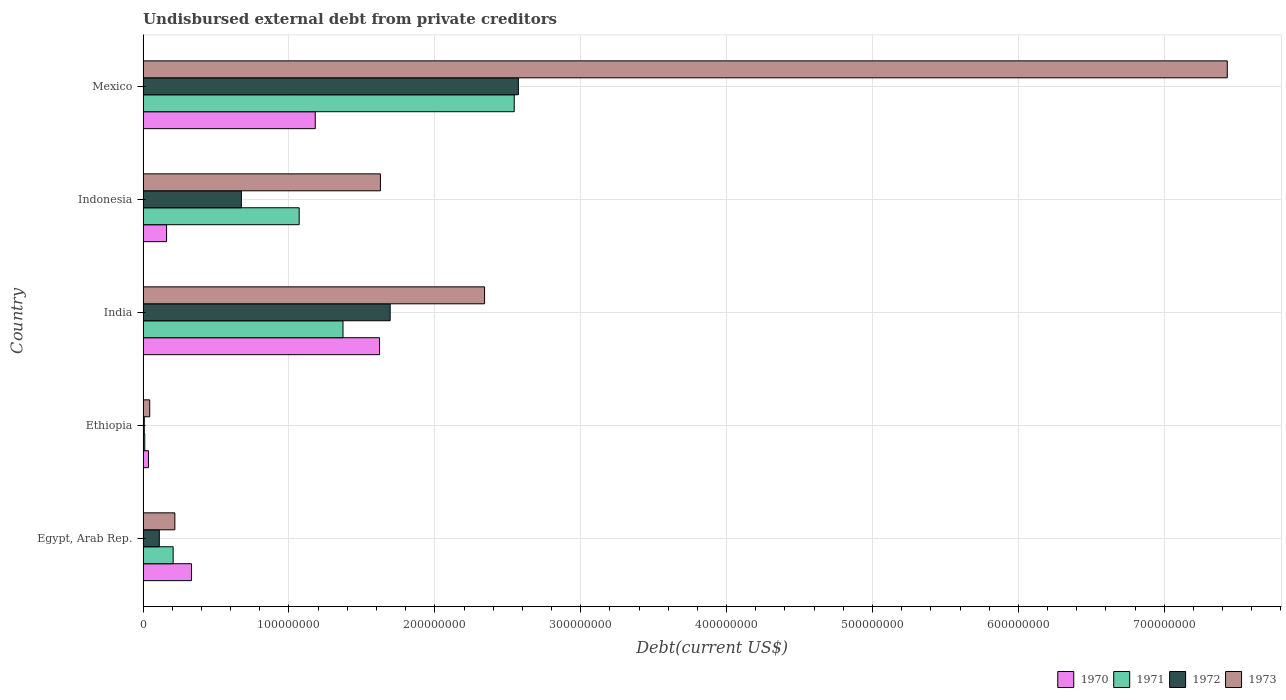Are the number of bars on each tick of the Y-axis equal?
Give a very brief answer. Yes. How many bars are there on the 3rd tick from the top?
Your answer should be very brief. 4. How many bars are there on the 1st tick from the bottom?
Your answer should be compact. 4. What is the label of the 4th group of bars from the top?
Ensure brevity in your answer.  Ethiopia. In how many cases, is the number of bars for a given country not equal to the number of legend labels?
Offer a terse response. 0. What is the total debt in 1970 in Indonesia?
Offer a very short reply. 1.61e+07. Across all countries, what is the maximum total debt in 1972?
Provide a short and direct response. 2.57e+08. Across all countries, what is the minimum total debt in 1970?
Provide a short and direct response. 3.70e+06. In which country was the total debt in 1973 minimum?
Keep it short and to the point. Ethiopia. What is the total total debt in 1973 in the graph?
Provide a short and direct response. 1.17e+09. What is the difference between the total debt in 1972 in Indonesia and that in Mexico?
Your answer should be compact. -1.90e+08. What is the difference between the total debt in 1971 in India and the total debt in 1973 in Indonesia?
Keep it short and to the point. -2.56e+07. What is the average total debt in 1970 per country?
Your answer should be compact. 6.66e+07. What is the difference between the total debt in 1971 and total debt in 1973 in Egypt, Arab Rep.?
Your response must be concise. -1.17e+06. In how many countries, is the total debt in 1973 greater than 460000000 US$?
Offer a terse response. 1. What is the ratio of the total debt in 1972 in Egypt, Arab Rep. to that in India?
Make the answer very short. 0.07. Is the total debt in 1972 in India less than that in Mexico?
Provide a succinct answer. Yes. What is the difference between the highest and the second highest total debt in 1971?
Keep it short and to the point. 1.17e+08. What is the difference between the highest and the lowest total debt in 1973?
Keep it short and to the point. 7.39e+08. In how many countries, is the total debt in 1971 greater than the average total debt in 1971 taken over all countries?
Give a very brief answer. 3. Is the sum of the total debt in 1970 in India and Indonesia greater than the maximum total debt in 1973 across all countries?
Make the answer very short. No. What does the 1st bar from the top in India represents?
Provide a short and direct response. 1973. Are all the bars in the graph horizontal?
Offer a very short reply. Yes. How many countries are there in the graph?
Your response must be concise. 5. What is the difference between two consecutive major ticks on the X-axis?
Offer a terse response. 1.00e+08. Are the values on the major ticks of X-axis written in scientific E-notation?
Ensure brevity in your answer.  No. Does the graph contain any zero values?
Ensure brevity in your answer.  No. Does the graph contain grids?
Your answer should be very brief. Yes. Where does the legend appear in the graph?
Ensure brevity in your answer.  Bottom right. How are the legend labels stacked?
Offer a very short reply. Horizontal. What is the title of the graph?
Keep it short and to the point. Undisbursed external debt from private creditors. What is the label or title of the X-axis?
Ensure brevity in your answer.  Debt(current US$). What is the label or title of the Y-axis?
Your response must be concise. Country. What is the Debt(current US$) of 1970 in Egypt, Arab Rep.?
Your answer should be compact. 3.32e+07. What is the Debt(current US$) in 1971 in Egypt, Arab Rep.?
Your answer should be compact. 2.06e+07. What is the Debt(current US$) in 1972 in Egypt, Arab Rep.?
Make the answer very short. 1.11e+07. What is the Debt(current US$) in 1973 in Egypt, Arab Rep.?
Offer a very short reply. 2.18e+07. What is the Debt(current US$) of 1970 in Ethiopia?
Ensure brevity in your answer.  3.70e+06. What is the Debt(current US$) in 1971 in Ethiopia?
Give a very brief answer. 1.16e+06. What is the Debt(current US$) of 1972 in Ethiopia?
Keep it short and to the point. 8.20e+05. What is the Debt(current US$) in 1973 in Ethiopia?
Provide a succinct answer. 4.57e+06. What is the Debt(current US$) of 1970 in India?
Your answer should be compact. 1.62e+08. What is the Debt(current US$) in 1971 in India?
Keep it short and to the point. 1.37e+08. What is the Debt(current US$) in 1972 in India?
Your response must be concise. 1.69e+08. What is the Debt(current US$) in 1973 in India?
Offer a very short reply. 2.34e+08. What is the Debt(current US$) in 1970 in Indonesia?
Give a very brief answer. 1.61e+07. What is the Debt(current US$) of 1971 in Indonesia?
Your answer should be compact. 1.07e+08. What is the Debt(current US$) in 1972 in Indonesia?
Ensure brevity in your answer.  6.74e+07. What is the Debt(current US$) in 1973 in Indonesia?
Offer a very short reply. 1.63e+08. What is the Debt(current US$) of 1970 in Mexico?
Give a very brief answer. 1.18e+08. What is the Debt(current US$) of 1971 in Mexico?
Provide a succinct answer. 2.54e+08. What is the Debt(current US$) in 1972 in Mexico?
Offer a terse response. 2.57e+08. What is the Debt(current US$) in 1973 in Mexico?
Your answer should be very brief. 7.43e+08. Across all countries, what is the maximum Debt(current US$) of 1970?
Your answer should be very brief. 1.62e+08. Across all countries, what is the maximum Debt(current US$) in 1971?
Give a very brief answer. 2.54e+08. Across all countries, what is the maximum Debt(current US$) in 1972?
Offer a very short reply. 2.57e+08. Across all countries, what is the maximum Debt(current US$) of 1973?
Make the answer very short. 7.43e+08. Across all countries, what is the minimum Debt(current US$) of 1970?
Your response must be concise. 3.70e+06. Across all countries, what is the minimum Debt(current US$) of 1971?
Give a very brief answer. 1.16e+06. Across all countries, what is the minimum Debt(current US$) in 1972?
Ensure brevity in your answer.  8.20e+05. Across all countries, what is the minimum Debt(current US$) of 1973?
Provide a succinct answer. 4.57e+06. What is the total Debt(current US$) of 1970 in the graph?
Provide a succinct answer. 3.33e+08. What is the total Debt(current US$) of 1971 in the graph?
Your response must be concise. 5.20e+08. What is the total Debt(current US$) of 1972 in the graph?
Provide a short and direct response. 5.06e+08. What is the total Debt(current US$) in 1973 in the graph?
Keep it short and to the point. 1.17e+09. What is the difference between the Debt(current US$) in 1970 in Egypt, Arab Rep. and that in Ethiopia?
Make the answer very short. 2.95e+07. What is the difference between the Debt(current US$) in 1971 in Egypt, Arab Rep. and that in Ethiopia?
Offer a very short reply. 1.95e+07. What is the difference between the Debt(current US$) in 1972 in Egypt, Arab Rep. and that in Ethiopia?
Give a very brief answer. 1.03e+07. What is the difference between the Debt(current US$) in 1973 in Egypt, Arab Rep. and that in Ethiopia?
Your response must be concise. 1.72e+07. What is the difference between the Debt(current US$) of 1970 in Egypt, Arab Rep. and that in India?
Your answer should be very brief. -1.29e+08. What is the difference between the Debt(current US$) in 1971 in Egypt, Arab Rep. and that in India?
Your answer should be very brief. -1.16e+08. What is the difference between the Debt(current US$) in 1972 in Egypt, Arab Rep. and that in India?
Your response must be concise. -1.58e+08. What is the difference between the Debt(current US$) in 1973 in Egypt, Arab Rep. and that in India?
Ensure brevity in your answer.  -2.12e+08. What is the difference between the Debt(current US$) in 1970 in Egypt, Arab Rep. and that in Indonesia?
Offer a very short reply. 1.71e+07. What is the difference between the Debt(current US$) in 1971 in Egypt, Arab Rep. and that in Indonesia?
Offer a very short reply. -8.64e+07. What is the difference between the Debt(current US$) of 1972 in Egypt, Arab Rep. and that in Indonesia?
Keep it short and to the point. -5.62e+07. What is the difference between the Debt(current US$) in 1973 in Egypt, Arab Rep. and that in Indonesia?
Keep it short and to the point. -1.41e+08. What is the difference between the Debt(current US$) in 1970 in Egypt, Arab Rep. and that in Mexico?
Keep it short and to the point. -8.48e+07. What is the difference between the Debt(current US$) of 1971 in Egypt, Arab Rep. and that in Mexico?
Your answer should be compact. -2.34e+08. What is the difference between the Debt(current US$) of 1972 in Egypt, Arab Rep. and that in Mexico?
Make the answer very short. -2.46e+08. What is the difference between the Debt(current US$) in 1973 in Egypt, Arab Rep. and that in Mexico?
Your answer should be very brief. -7.21e+08. What is the difference between the Debt(current US$) of 1970 in Ethiopia and that in India?
Offer a terse response. -1.58e+08. What is the difference between the Debt(current US$) in 1971 in Ethiopia and that in India?
Give a very brief answer. -1.36e+08. What is the difference between the Debt(current US$) of 1972 in Ethiopia and that in India?
Your answer should be very brief. -1.69e+08. What is the difference between the Debt(current US$) in 1973 in Ethiopia and that in India?
Keep it short and to the point. -2.30e+08. What is the difference between the Debt(current US$) of 1970 in Ethiopia and that in Indonesia?
Your answer should be very brief. -1.24e+07. What is the difference between the Debt(current US$) of 1971 in Ethiopia and that in Indonesia?
Provide a succinct answer. -1.06e+08. What is the difference between the Debt(current US$) of 1972 in Ethiopia and that in Indonesia?
Offer a terse response. -6.66e+07. What is the difference between the Debt(current US$) in 1973 in Ethiopia and that in Indonesia?
Your answer should be very brief. -1.58e+08. What is the difference between the Debt(current US$) of 1970 in Ethiopia and that in Mexico?
Provide a succinct answer. -1.14e+08. What is the difference between the Debt(current US$) of 1971 in Ethiopia and that in Mexico?
Your answer should be compact. -2.53e+08. What is the difference between the Debt(current US$) in 1972 in Ethiopia and that in Mexico?
Your answer should be very brief. -2.56e+08. What is the difference between the Debt(current US$) in 1973 in Ethiopia and that in Mexico?
Your answer should be very brief. -7.39e+08. What is the difference between the Debt(current US$) of 1970 in India and that in Indonesia?
Provide a short and direct response. 1.46e+08. What is the difference between the Debt(current US$) in 1971 in India and that in Indonesia?
Ensure brevity in your answer.  3.00e+07. What is the difference between the Debt(current US$) in 1972 in India and that in Indonesia?
Provide a short and direct response. 1.02e+08. What is the difference between the Debt(current US$) of 1973 in India and that in Indonesia?
Ensure brevity in your answer.  7.14e+07. What is the difference between the Debt(current US$) in 1970 in India and that in Mexico?
Your answer should be very brief. 4.41e+07. What is the difference between the Debt(current US$) in 1971 in India and that in Mexico?
Offer a very short reply. -1.17e+08. What is the difference between the Debt(current US$) of 1972 in India and that in Mexico?
Your answer should be very brief. -8.79e+07. What is the difference between the Debt(current US$) in 1973 in India and that in Mexico?
Make the answer very short. -5.09e+08. What is the difference between the Debt(current US$) in 1970 in Indonesia and that in Mexico?
Provide a succinct answer. -1.02e+08. What is the difference between the Debt(current US$) in 1971 in Indonesia and that in Mexico?
Provide a succinct answer. -1.47e+08. What is the difference between the Debt(current US$) in 1972 in Indonesia and that in Mexico?
Provide a short and direct response. -1.90e+08. What is the difference between the Debt(current US$) in 1973 in Indonesia and that in Mexico?
Make the answer very short. -5.81e+08. What is the difference between the Debt(current US$) in 1970 in Egypt, Arab Rep. and the Debt(current US$) in 1971 in Ethiopia?
Offer a terse response. 3.21e+07. What is the difference between the Debt(current US$) of 1970 in Egypt, Arab Rep. and the Debt(current US$) of 1972 in Ethiopia?
Offer a very short reply. 3.24e+07. What is the difference between the Debt(current US$) of 1970 in Egypt, Arab Rep. and the Debt(current US$) of 1973 in Ethiopia?
Provide a short and direct response. 2.87e+07. What is the difference between the Debt(current US$) in 1971 in Egypt, Arab Rep. and the Debt(current US$) in 1972 in Ethiopia?
Provide a short and direct response. 1.98e+07. What is the difference between the Debt(current US$) of 1971 in Egypt, Arab Rep. and the Debt(current US$) of 1973 in Ethiopia?
Make the answer very short. 1.61e+07. What is the difference between the Debt(current US$) in 1972 in Egypt, Arab Rep. and the Debt(current US$) in 1973 in Ethiopia?
Make the answer very short. 6.56e+06. What is the difference between the Debt(current US$) in 1970 in Egypt, Arab Rep. and the Debt(current US$) in 1971 in India?
Offer a very short reply. -1.04e+08. What is the difference between the Debt(current US$) in 1970 in Egypt, Arab Rep. and the Debt(current US$) in 1972 in India?
Ensure brevity in your answer.  -1.36e+08. What is the difference between the Debt(current US$) of 1970 in Egypt, Arab Rep. and the Debt(current US$) of 1973 in India?
Your answer should be compact. -2.01e+08. What is the difference between the Debt(current US$) of 1971 in Egypt, Arab Rep. and the Debt(current US$) of 1972 in India?
Make the answer very short. -1.49e+08. What is the difference between the Debt(current US$) of 1971 in Egypt, Arab Rep. and the Debt(current US$) of 1973 in India?
Your answer should be compact. -2.13e+08. What is the difference between the Debt(current US$) of 1972 in Egypt, Arab Rep. and the Debt(current US$) of 1973 in India?
Give a very brief answer. -2.23e+08. What is the difference between the Debt(current US$) of 1970 in Egypt, Arab Rep. and the Debt(current US$) of 1971 in Indonesia?
Give a very brief answer. -7.38e+07. What is the difference between the Debt(current US$) in 1970 in Egypt, Arab Rep. and the Debt(current US$) in 1972 in Indonesia?
Give a very brief answer. -3.42e+07. What is the difference between the Debt(current US$) of 1970 in Egypt, Arab Rep. and the Debt(current US$) of 1973 in Indonesia?
Give a very brief answer. -1.29e+08. What is the difference between the Debt(current US$) in 1971 in Egypt, Arab Rep. and the Debt(current US$) in 1972 in Indonesia?
Your answer should be very brief. -4.67e+07. What is the difference between the Debt(current US$) of 1971 in Egypt, Arab Rep. and the Debt(current US$) of 1973 in Indonesia?
Keep it short and to the point. -1.42e+08. What is the difference between the Debt(current US$) in 1972 in Egypt, Arab Rep. and the Debt(current US$) in 1973 in Indonesia?
Make the answer very short. -1.52e+08. What is the difference between the Debt(current US$) of 1970 in Egypt, Arab Rep. and the Debt(current US$) of 1971 in Mexico?
Your answer should be compact. -2.21e+08. What is the difference between the Debt(current US$) in 1970 in Egypt, Arab Rep. and the Debt(current US$) in 1972 in Mexico?
Make the answer very short. -2.24e+08. What is the difference between the Debt(current US$) in 1970 in Egypt, Arab Rep. and the Debt(current US$) in 1973 in Mexico?
Your response must be concise. -7.10e+08. What is the difference between the Debt(current US$) in 1971 in Egypt, Arab Rep. and the Debt(current US$) in 1972 in Mexico?
Offer a terse response. -2.37e+08. What is the difference between the Debt(current US$) of 1971 in Egypt, Arab Rep. and the Debt(current US$) of 1973 in Mexico?
Your answer should be compact. -7.23e+08. What is the difference between the Debt(current US$) of 1972 in Egypt, Arab Rep. and the Debt(current US$) of 1973 in Mexico?
Provide a short and direct response. -7.32e+08. What is the difference between the Debt(current US$) in 1970 in Ethiopia and the Debt(current US$) in 1971 in India?
Provide a succinct answer. -1.33e+08. What is the difference between the Debt(current US$) of 1970 in Ethiopia and the Debt(current US$) of 1972 in India?
Provide a succinct answer. -1.66e+08. What is the difference between the Debt(current US$) of 1970 in Ethiopia and the Debt(current US$) of 1973 in India?
Offer a terse response. -2.30e+08. What is the difference between the Debt(current US$) of 1971 in Ethiopia and the Debt(current US$) of 1972 in India?
Provide a succinct answer. -1.68e+08. What is the difference between the Debt(current US$) of 1971 in Ethiopia and the Debt(current US$) of 1973 in India?
Ensure brevity in your answer.  -2.33e+08. What is the difference between the Debt(current US$) of 1972 in Ethiopia and the Debt(current US$) of 1973 in India?
Keep it short and to the point. -2.33e+08. What is the difference between the Debt(current US$) in 1970 in Ethiopia and the Debt(current US$) in 1971 in Indonesia?
Make the answer very short. -1.03e+08. What is the difference between the Debt(current US$) of 1970 in Ethiopia and the Debt(current US$) of 1972 in Indonesia?
Offer a very short reply. -6.37e+07. What is the difference between the Debt(current US$) in 1970 in Ethiopia and the Debt(current US$) in 1973 in Indonesia?
Provide a short and direct response. -1.59e+08. What is the difference between the Debt(current US$) of 1971 in Ethiopia and the Debt(current US$) of 1972 in Indonesia?
Your response must be concise. -6.62e+07. What is the difference between the Debt(current US$) of 1971 in Ethiopia and the Debt(current US$) of 1973 in Indonesia?
Your answer should be compact. -1.62e+08. What is the difference between the Debt(current US$) in 1972 in Ethiopia and the Debt(current US$) in 1973 in Indonesia?
Provide a short and direct response. -1.62e+08. What is the difference between the Debt(current US$) in 1970 in Ethiopia and the Debt(current US$) in 1971 in Mexico?
Offer a very short reply. -2.51e+08. What is the difference between the Debt(current US$) in 1970 in Ethiopia and the Debt(current US$) in 1972 in Mexico?
Provide a short and direct response. -2.54e+08. What is the difference between the Debt(current US$) of 1970 in Ethiopia and the Debt(current US$) of 1973 in Mexico?
Offer a terse response. -7.40e+08. What is the difference between the Debt(current US$) of 1971 in Ethiopia and the Debt(current US$) of 1972 in Mexico?
Provide a succinct answer. -2.56e+08. What is the difference between the Debt(current US$) of 1971 in Ethiopia and the Debt(current US$) of 1973 in Mexico?
Your answer should be compact. -7.42e+08. What is the difference between the Debt(current US$) of 1972 in Ethiopia and the Debt(current US$) of 1973 in Mexico?
Offer a very short reply. -7.42e+08. What is the difference between the Debt(current US$) in 1970 in India and the Debt(current US$) in 1971 in Indonesia?
Ensure brevity in your answer.  5.51e+07. What is the difference between the Debt(current US$) of 1970 in India and the Debt(current US$) of 1972 in Indonesia?
Ensure brevity in your answer.  9.47e+07. What is the difference between the Debt(current US$) of 1970 in India and the Debt(current US$) of 1973 in Indonesia?
Your response must be concise. -5.84e+05. What is the difference between the Debt(current US$) in 1971 in India and the Debt(current US$) in 1972 in Indonesia?
Give a very brief answer. 6.97e+07. What is the difference between the Debt(current US$) in 1971 in India and the Debt(current US$) in 1973 in Indonesia?
Make the answer very short. -2.56e+07. What is the difference between the Debt(current US$) in 1972 in India and the Debt(current US$) in 1973 in Indonesia?
Provide a short and direct response. 6.68e+06. What is the difference between the Debt(current US$) of 1970 in India and the Debt(current US$) of 1971 in Mexico?
Offer a terse response. -9.23e+07. What is the difference between the Debt(current US$) of 1970 in India and the Debt(current US$) of 1972 in Mexico?
Provide a succinct answer. -9.51e+07. What is the difference between the Debt(current US$) of 1970 in India and the Debt(current US$) of 1973 in Mexico?
Provide a succinct answer. -5.81e+08. What is the difference between the Debt(current US$) of 1971 in India and the Debt(current US$) of 1972 in Mexico?
Give a very brief answer. -1.20e+08. What is the difference between the Debt(current US$) of 1971 in India and the Debt(current US$) of 1973 in Mexico?
Keep it short and to the point. -6.06e+08. What is the difference between the Debt(current US$) of 1972 in India and the Debt(current US$) of 1973 in Mexico?
Offer a terse response. -5.74e+08. What is the difference between the Debt(current US$) in 1970 in Indonesia and the Debt(current US$) in 1971 in Mexico?
Offer a very short reply. -2.38e+08. What is the difference between the Debt(current US$) of 1970 in Indonesia and the Debt(current US$) of 1972 in Mexico?
Your answer should be compact. -2.41e+08. What is the difference between the Debt(current US$) in 1970 in Indonesia and the Debt(current US$) in 1973 in Mexico?
Your answer should be very brief. -7.27e+08. What is the difference between the Debt(current US$) in 1971 in Indonesia and the Debt(current US$) in 1972 in Mexico?
Your response must be concise. -1.50e+08. What is the difference between the Debt(current US$) in 1971 in Indonesia and the Debt(current US$) in 1973 in Mexico?
Offer a terse response. -6.36e+08. What is the difference between the Debt(current US$) in 1972 in Indonesia and the Debt(current US$) in 1973 in Mexico?
Provide a short and direct response. -6.76e+08. What is the average Debt(current US$) of 1970 per country?
Your answer should be very brief. 6.66e+07. What is the average Debt(current US$) in 1971 per country?
Your answer should be very brief. 1.04e+08. What is the average Debt(current US$) of 1972 per country?
Give a very brief answer. 1.01e+08. What is the average Debt(current US$) of 1973 per country?
Offer a terse response. 2.33e+08. What is the difference between the Debt(current US$) in 1970 and Debt(current US$) in 1971 in Egypt, Arab Rep.?
Offer a very short reply. 1.26e+07. What is the difference between the Debt(current US$) in 1970 and Debt(current US$) in 1972 in Egypt, Arab Rep.?
Provide a succinct answer. 2.21e+07. What is the difference between the Debt(current US$) of 1970 and Debt(current US$) of 1973 in Egypt, Arab Rep.?
Your answer should be very brief. 1.14e+07. What is the difference between the Debt(current US$) in 1971 and Debt(current US$) in 1972 in Egypt, Arab Rep.?
Your response must be concise. 9.50e+06. What is the difference between the Debt(current US$) of 1971 and Debt(current US$) of 1973 in Egypt, Arab Rep.?
Offer a terse response. -1.17e+06. What is the difference between the Debt(current US$) of 1972 and Debt(current US$) of 1973 in Egypt, Arab Rep.?
Your answer should be very brief. -1.07e+07. What is the difference between the Debt(current US$) of 1970 and Debt(current US$) of 1971 in Ethiopia?
Ensure brevity in your answer.  2.53e+06. What is the difference between the Debt(current US$) of 1970 and Debt(current US$) of 1972 in Ethiopia?
Offer a very short reply. 2.88e+06. What is the difference between the Debt(current US$) of 1970 and Debt(current US$) of 1973 in Ethiopia?
Provide a succinct answer. -8.70e+05. What is the difference between the Debt(current US$) in 1971 and Debt(current US$) in 1972 in Ethiopia?
Offer a terse response. 3.45e+05. What is the difference between the Debt(current US$) in 1971 and Debt(current US$) in 1973 in Ethiopia?
Give a very brief answer. -3.40e+06. What is the difference between the Debt(current US$) of 1972 and Debt(current US$) of 1973 in Ethiopia?
Keep it short and to the point. -3.75e+06. What is the difference between the Debt(current US$) of 1970 and Debt(current US$) of 1971 in India?
Provide a short and direct response. 2.51e+07. What is the difference between the Debt(current US$) in 1970 and Debt(current US$) in 1972 in India?
Your response must be concise. -7.26e+06. What is the difference between the Debt(current US$) of 1970 and Debt(current US$) of 1973 in India?
Provide a short and direct response. -7.20e+07. What is the difference between the Debt(current US$) of 1971 and Debt(current US$) of 1972 in India?
Make the answer very short. -3.23e+07. What is the difference between the Debt(current US$) of 1971 and Debt(current US$) of 1973 in India?
Provide a succinct answer. -9.70e+07. What is the difference between the Debt(current US$) in 1972 and Debt(current US$) in 1973 in India?
Provide a short and direct response. -6.47e+07. What is the difference between the Debt(current US$) of 1970 and Debt(current US$) of 1971 in Indonesia?
Your answer should be very brief. -9.09e+07. What is the difference between the Debt(current US$) of 1970 and Debt(current US$) of 1972 in Indonesia?
Offer a terse response. -5.12e+07. What is the difference between the Debt(current US$) in 1970 and Debt(current US$) in 1973 in Indonesia?
Ensure brevity in your answer.  -1.47e+08. What is the difference between the Debt(current US$) in 1971 and Debt(current US$) in 1972 in Indonesia?
Keep it short and to the point. 3.96e+07. What is the difference between the Debt(current US$) in 1971 and Debt(current US$) in 1973 in Indonesia?
Make the answer very short. -5.57e+07. What is the difference between the Debt(current US$) in 1972 and Debt(current US$) in 1973 in Indonesia?
Make the answer very short. -9.53e+07. What is the difference between the Debt(current US$) of 1970 and Debt(current US$) of 1971 in Mexico?
Provide a short and direct response. -1.36e+08. What is the difference between the Debt(current US$) of 1970 and Debt(current US$) of 1972 in Mexico?
Your response must be concise. -1.39e+08. What is the difference between the Debt(current US$) in 1970 and Debt(current US$) in 1973 in Mexico?
Make the answer very short. -6.25e+08. What is the difference between the Debt(current US$) of 1971 and Debt(current US$) of 1972 in Mexico?
Make the answer very short. -2.84e+06. What is the difference between the Debt(current US$) in 1971 and Debt(current US$) in 1973 in Mexico?
Keep it short and to the point. -4.89e+08. What is the difference between the Debt(current US$) in 1972 and Debt(current US$) in 1973 in Mexico?
Make the answer very short. -4.86e+08. What is the ratio of the Debt(current US$) of 1970 in Egypt, Arab Rep. to that in Ethiopia?
Give a very brief answer. 8.99. What is the ratio of the Debt(current US$) in 1971 in Egypt, Arab Rep. to that in Ethiopia?
Ensure brevity in your answer.  17.71. What is the ratio of the Debt(current US$) in 1972 in Egypt, Arab Rep. to that in Ethiopia?
Your answer should be very brief. 13.57. What is the ratio of the Debt(current US$) of 1973 in Egypt, Arab Rep. to that in Ethiopia?
Give a very brief answer. 4.77. What is the ratio of the Debt(current US$) in 1970 in Egypt, Arab Rep. to that in India?
Give a very brief answer. 0.2. What is the ratio of the Debt(current US$) in 1971 in Egypt, Arab Rep. to that in India?
Offer a very short reply. 0.15. What is the ratio of the Debt(current US$) of 1972 in Egypt, Arab Rep. to that in India?
Your answer should be compact. 0.07. What is the ratio of the Debt(current US$) of 1973 in Egypt, Arab Rep. to that in India?
Offer a terse response. 0.09. What is the ratio of the Debt(current US$) of 1970 in Egypt, Arab Rep. to that in Indonesia?
Provide a short and direct response. 2.06. What is the ratio of the Debt(current US$) of 1971 in Egypt, Arab Rep. to that in Indonesia?
Provide a short and direct response. 0.19. What is the ratio of the Debt(current US$) of 1972 in Egypt, Arab Rep. to that in Indonesia?
Make the answer very short. 0.17. What is the ratio of the Debt(current US$) of 1973 in Egypt, Arab Rep. to that in Indonesia?
Give a very brief answer. 0.13. What is the ratio of the Debt(current US$) in 1970 in Egypt, Arab Rep. to that in Mexico?
Provide a short and direct response. 0.28. What is the ratio of the Debt(current US$) of 1971 in Egypt, Arab Rep. to that in Mexico?
Offer a very short reply. 0.08. What is the ratio of the Debt(current US$) of 1972 in Egypt, Arab Rep. to that in Mexico?
Provide a short and direct response. 0.04. What is the ratio of the Debt(current US$) of 1973 in Egypt, Arab Rep. to that in Mexico?
Offer a terse response. 0.03. What is the ratio of the Debt(current US$) of 1970 in Ethiopia to that in India?
Offer a very short reply. 0.02. What is the ratio of the Debt(current US$) in 1971 in Ethiopia to that in India?
Your response must be concise. 0.01. What is the ratio of the Debt(current US$) of 1972 in Ethiopia to that in India?
Keep it short and to the point. 0. What is the ratio of the Debt(current US$) in 1973 in Ethiopia to that in India?
Make the answer very short. 0.02. What is the ratio of the Debt(current US$) in 1970 in Ethiopia to that in Indonesia?
Your answer should be compact. 0.23. What is the ratio of the Debt(current US$) in 1971 in Ethiopia to that in Indonesia?
Your response must be concise. 0.01. What is the ratio of the Debt(current US$) of 1972 in Ethiopia to that in Indonesia?
Make the answer very short. 0.01. What is the ratio of the Debt(current US$) of 1973 in Ethiopia to that in Indonesia?
Keep it short and to the point. 0.03. What is the ratio of the Debt(current US$) in 1970 in Ethiopia to that in Mexico?
Give a very brief answer. 0.03. What is the ratio of the Debt(current US$) in 1971 in Ethiopia to that in Mexico?
Keep it short and to the point. 0. What is the ratio of the Debt(current US$) in 1972 in Ethiopia to that in Mexico?
Offer a terse response. 0. What is the ratio of the Debt(current US$) in 1973 in Ethiopia to that in Mexico?
Provide a succinct answer. 0.01. What is the ratio of the Debt(current US$) of 1970 in India to that in Indonesia?
Keep it short and to the point. 10.05. What is the ratio of the Debt(current US$) in 1971 in India to that in Indonesia?
Offer a very short reply. 1.28. What is the ratio of the Debt(current US$) in 1972 in India to that in Indonesia?
Provide a short and direct response. 2.51. What is the ratio of the Debt(current US$) of 1973 in India to that in Indonesia?
Your answer should be very brief. 1.44. What is the ratio of the Debt(current US$) of 1970 in India to that in Mexico?
Ensure brevity in your answer.  1.37. What is the ratio of the Debt(current US$) in 1971 in India to that in Mexico?
Make the answer very short. 0.54. What is the ratio of the Debt(current US$) in 1972 in India to that in Mexico?
Keep it short and to the point. 0.66. What is the ratio of the Debt(current US$) of 1973 in India to that in Mexico?
Offer a terse response. 0.32. What is the ratio of the Debt(current US$) in 1970 in Indonesia to that in Mexico?
Provide a short and direct response. 0.14. What is the ratio of the Debt(current US$) of 1971 in Indonesia to that in Mexico?
Make the answer very short. 0.42. What is the ratio of the Debt(current US$) in 1972 in Indonesia to that in Mexico?
Offer a very short reply. 0.26. What is the ratio of the Debt(current US$) in 1973 in Indonesia to that in Mexico?
Make the answer very short. 0.22. What is the difference between the highest and the second highest Debt(current US$) of 1970?
Offer a terse response. 4.41e+07. What is the difference between the highest and the second highest Debt(current US$) in 1971?
Offer a very short reply. 1.17e+08. What is the difference between the highest and the second highest Debt(current US$) of 1972?
Offer a terse response. 8.79e+07. What is the difference between the highest and the second highest Debt(current US$) in 1973?
Provide a short and direct response. 5.09e+08. What is the difference between the highest and the lowest Debt(current US$) in 1970?
Your answer should be compact. 1.58e+08. What is the difference between the highest and the lowest Debt(current US$) in 1971?
Provide a short and direct response. 2.53e+08. What is the difference between the highest and the lowest Debt(current US$) of 1972?
Offer a terse response. 2.56e+08. What is the difference between the highest and the lowest Debt(current US$) in 1973?
Offer a terse response. 7.39e+08. 